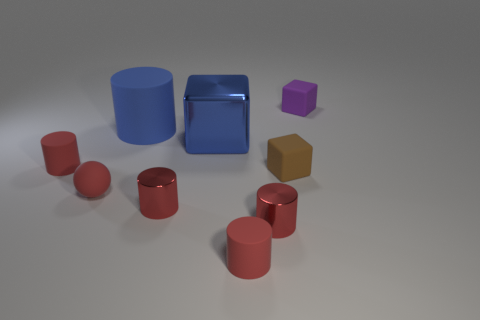There is a big thing that is the same color as the big cylinder; what is its shape?
Your response must be concise. Cube. How many other objects are the same shape as the blue matte object?
Your answer should be very brief. 4. There is a tiny red matte thing to the right of the large blue shiny thing; what shape is it?
Make the answer very short. Cylinder. Are there any small brown things made of the same material as the blue cylinder?
Your answer should be very brief. Yes. There is a tiny block that is in front of the blue rubber cylinder; is it the same color as the big matte cylinder?
Make the answer very short. No. The sphere has what size?
Give a very brief answer. Small. There is a small matte cylinder to the right of the small rubber thing on the left side of the red matte ball; are there any small brown things to the left of it?
Provide a short and direct response. No. There is a small purple matte cube; what number of matte objects are to the left of it?
Keep it short and to the point. 5. How many big rubber objects are the same color as the metal cube?
Keep it short and to the point. 1. What number of things are rubber blocks that are in front of the purple rubber object or objects that are in front of the brown rubber block?
Offer a very short reply. 5. 